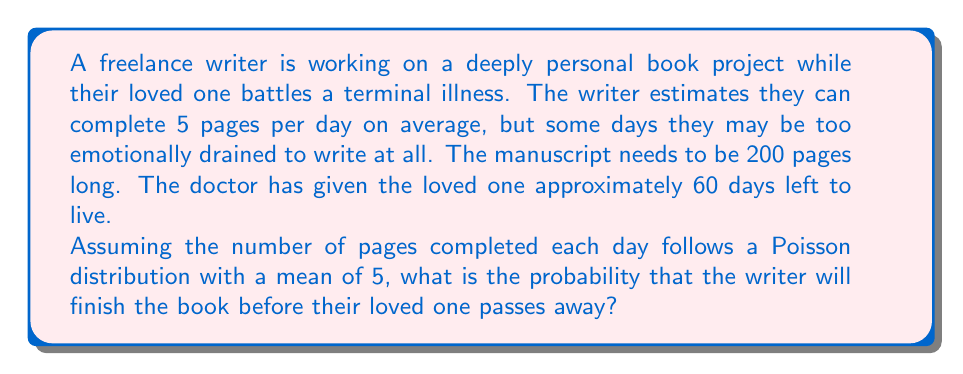Teach me how to tackle this problem. To solve this problem, we need to use the Poisson distribution and the central limit theorem. Let's break it down step-by-step:

1) First, we need to calculate the total number of pages that can be written in 60 days on average:
   $$ 60 \text{ days} \times 5 \text{ pages/day} = 300 \text{ pages} $$

2) The writer needs to complete 200 pages. We can model this as a sum of 60 independent Poisson random variables, each with mean 5.

3) By the central limit theorem, for a large number of trials (60 is sufficient), the sum of independent Poisson variables approaches a normal distribution.

4) The mean of this normal distribution is:
   $$ \mu = 60 \times 5 = 300 $$

5) The variance of a Poisson distribution is equal to its mean. So the variance of our normal approximation is:
   $$ \sigma^2 = 60 \times 5 = 300 $$

6) The standard deviation is therefore:
   $$ \sigma = \sqrt{300} \approx 17.32 $$

7) We want to find the probability of writing at least 200 pages. We can use the z-score formula:
   $$ z = \frac{x - \mu}{\sigma} = \frac{200 - 300}{17.32} \approx -5.77 $$

8) Using a standard normal distribution table or calculator, we can find the probability of a z-score less than or equal to -5.77.

9) This probability is extremely small (less than 0.0001), so the probability of writing 200 or more pages is:
   $$ 1 - P(Z \leq -5.77) \approx 0.9999 $$
Answer: The probability that the writer will finish the 200-page book within 60 days is approximately 0.9999 or 99.99%. 